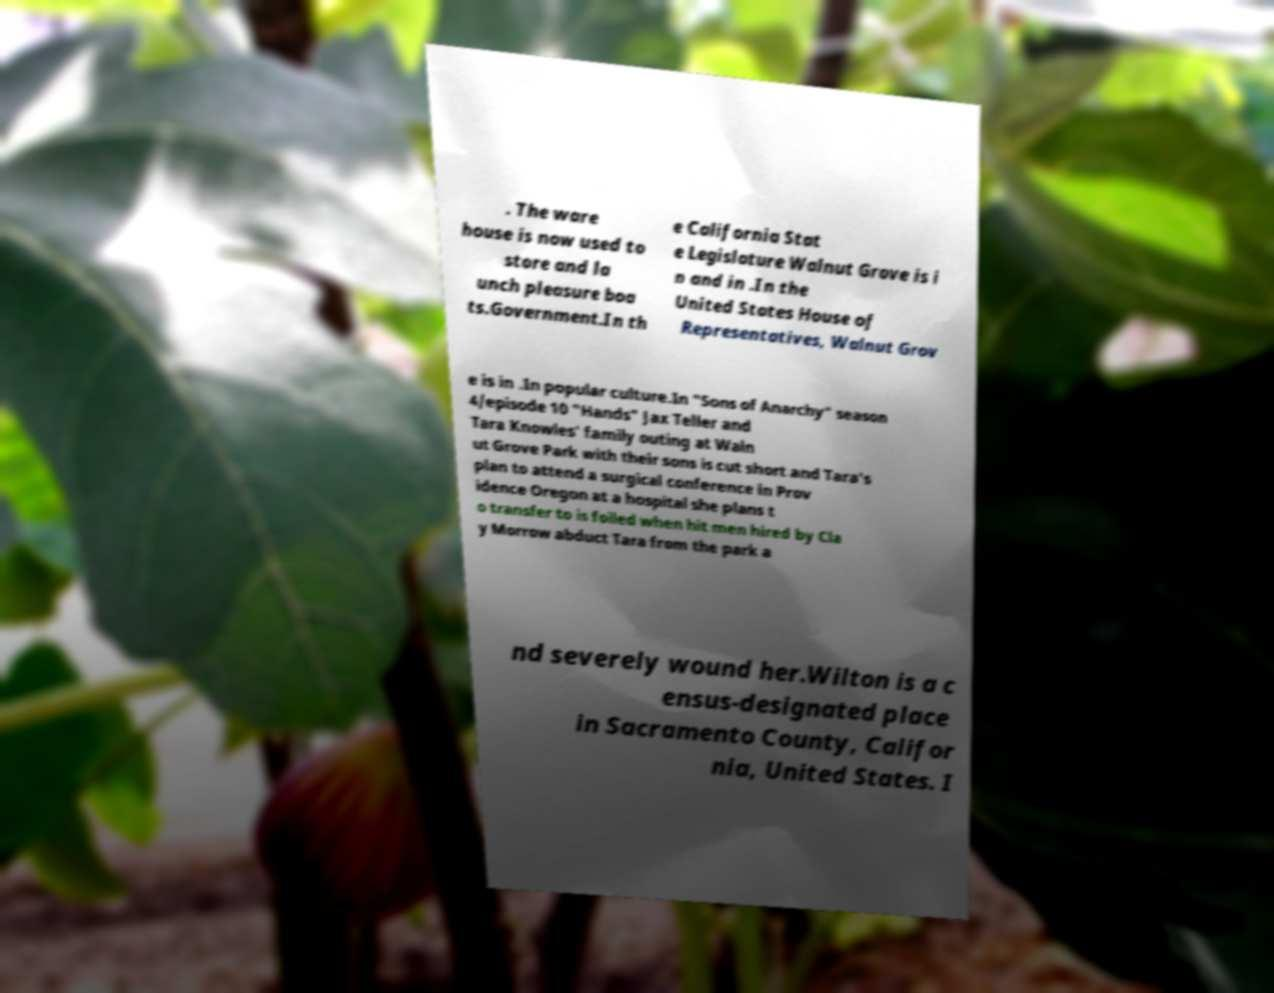For documentation purposes, I need the text within this image transcribed. Could you provide that? . The ware house is now used to store and la unch pleasure boa ts.Government.In th e California Stat e Legislature Walnut Grove is i n and in .In the United States House of Representatives, Walnut Grov e is in .In popular culture.In "Sons of Anarchy" season 4/episode 10 "Hands" Jax Teller and Tara Knowles' family outing at Waln ut Grove Park with their sons is cut short and Tara's plan to attend a surgical conference in Prov idence Oregon at a hospital she plans t o transfer to is foiled when hit men hired by Cla y Morrow abduct Tara from the park a nd severely wound her.Wilton is a c ensus-designated place in Sacramento County, Califor nia, United States. I 